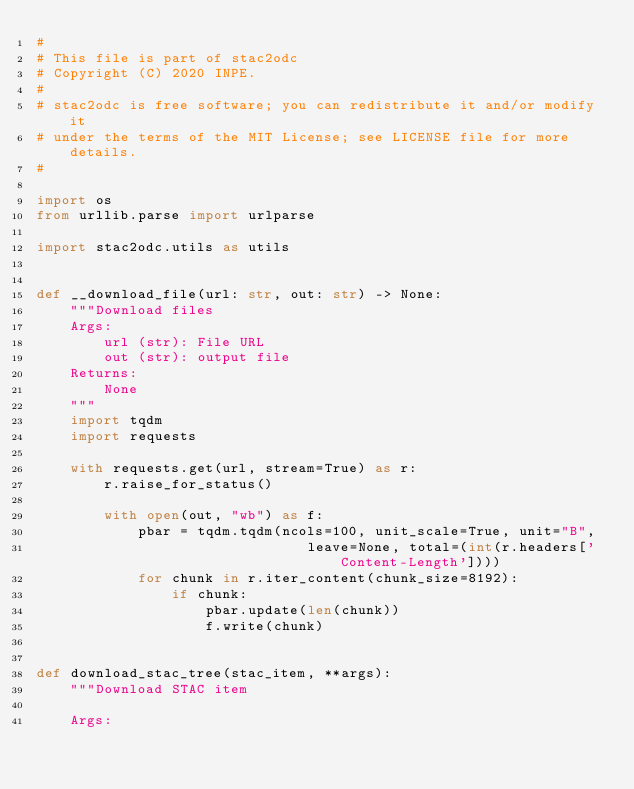<code> <loc_0><loc_0><loc_500><loc_500><_Python_>#
# This file is part of stac2odc
# Copyright (C) 2020 INPE.
#
# stac2odc is free software; you can redistribute it and/or modify it
# under the terms of the MIT License; see LICENSE file for more details.
#

import os
from urllib.parse import urlparse

import stac2odc.utils as utils


def __download_file(url: str, out: str) -> None:
    """Download files
    Args:
        url (str): File URL
        out (str): output file
    Returns:
        None
    """
    import tqdm
    import requests

    with requests.get(url, stream=True) as r:
        r.raise_for_status()

        with open(out, "wb") as f:
            pbar = tqdm.tqdm(ncols=100, unit_scale=True, unit="B",
                                leave=None, total=(int(r.headers['Content-Length'])))
            for chunk in r.iter_content(chunk_size=8192):
                if chunk:
                    pbar.update(len(chunk))
                    f.write(chunk)


def download_stac_tree(stac_item, **args):
    """Download STAC item
    
    Args:</code> 